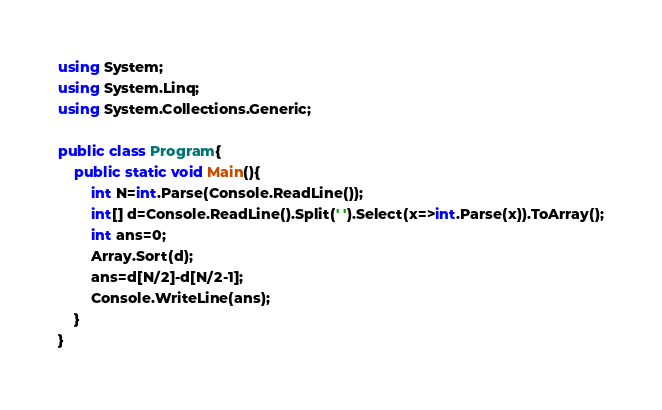Convert code to text. <code><loc_0><loc_0><loc_500><loc_500><_C#_>using System;
using System.Linq;
using System.Collections.Generic;

public class Program{
    public static void Main(){
        int N=int.Parse(Console.ReadLine());
        int[] d=Console.ReadLine().Split(' ').Select(x=>int.Parse(x)).ToArray();
        int ans=0;
        Array.Sort(d);
        ans=d[N/2]-d[N/2-1];
        Console.WriteLine(ans);
    }
}
</code> 